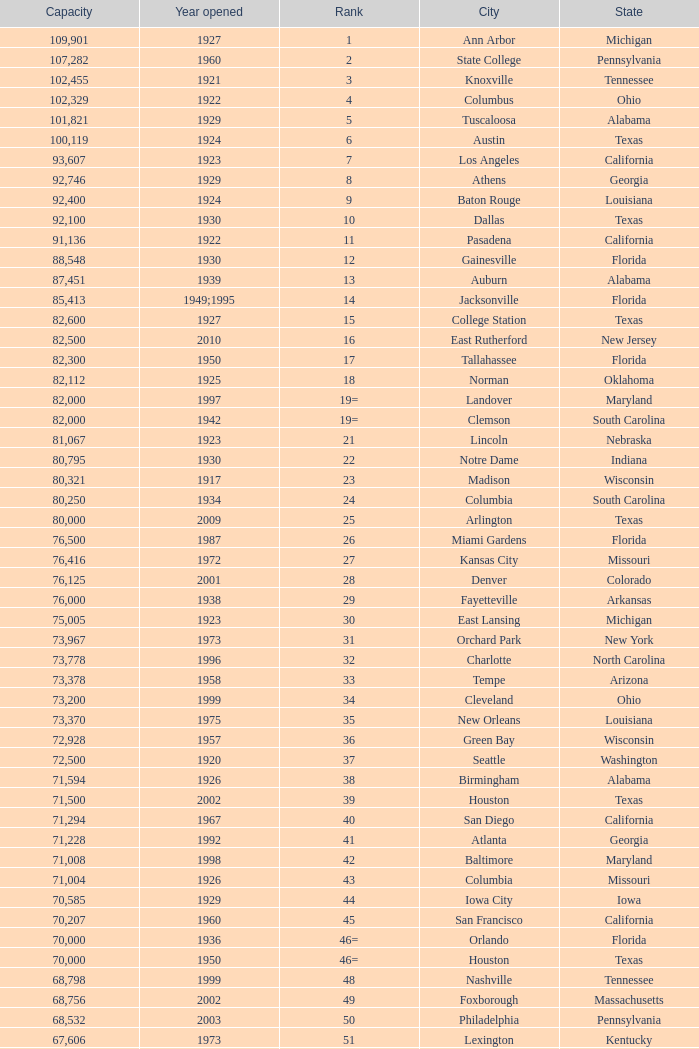What is the city in Alabama that opened in 1996? Huntsville. 